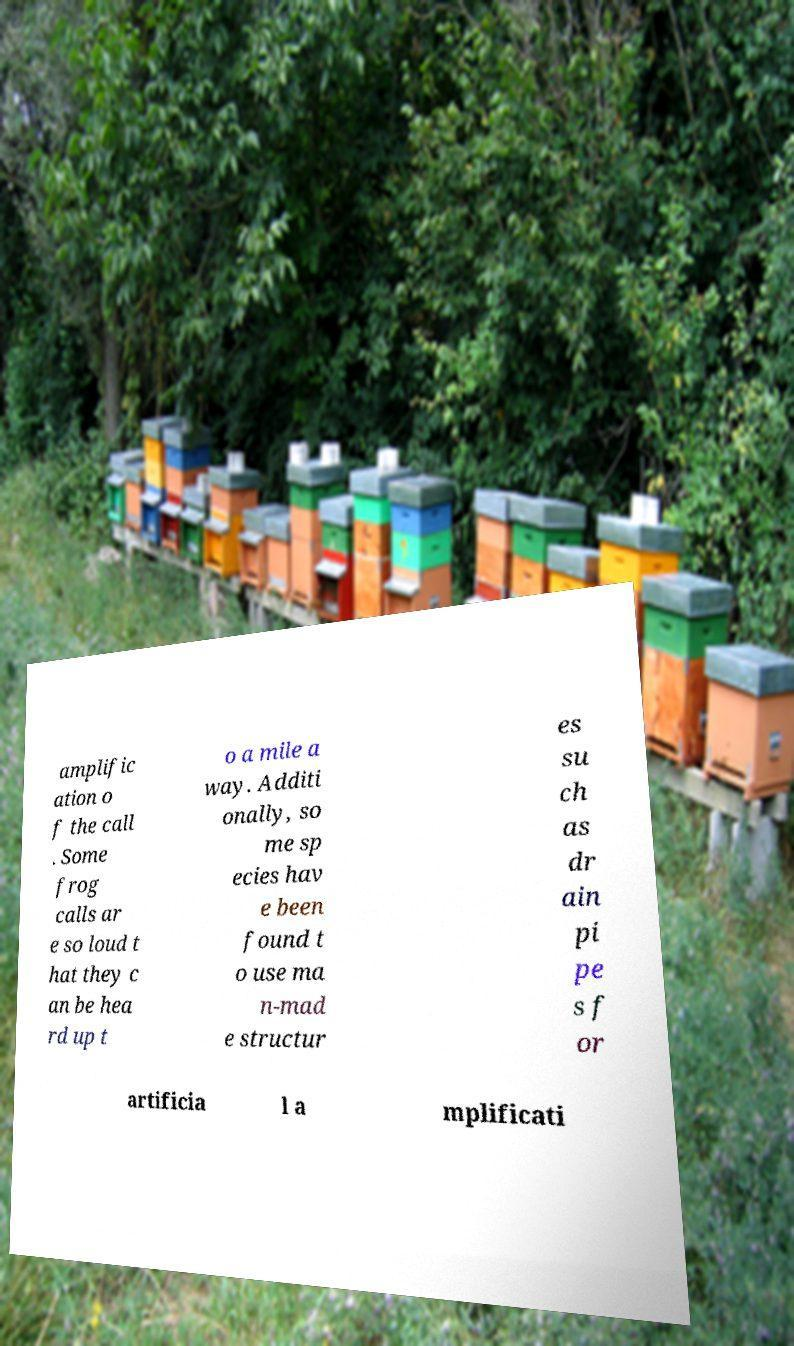Please identify and transcribe the text found in this image. amplific ation o f the call . Some frog calls ar e so loud t hat they c an be hea rd up t o a mile a way. Additi onally, so me sp ecies hav e been found t o use ma n-mad e structur es su ch as dr ain pi pe s f or artificia l a mplificati 